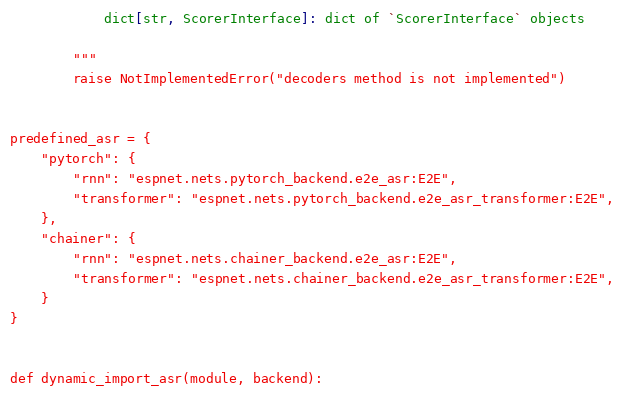<code> <loc_0><loc_0><loc_500><loc_500><_Python_>            dict[str, ScorerInterface]: dict of `ScorerInterface` objects

        """
        raise NotImplementedError("decoders method is not implemented")


predefined_asr = {
    "pytorch": {
        "rnn": "espnet.nets.pytorch_backend.e2e_asr:E2E",
        "transformer": "espnet.nets.pytorch_backend.e2e_asr_transformer:E2E",
    },
    "chainer": {
        "rnn": "espnet.nets.chainer_backend.e2e_asr:E2E",
        "transformer": "espnet.nets.chainer_backend.e2e_asr_transformer:E2E",
    }
}


def dynamic_import_asr(module, backend):</code> 